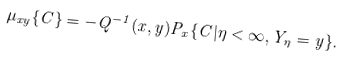<formula> <loc_0><loc_0><loc_500><loc_500>\mu _ { x y } \{ C \} = - Q ^ { - 1 } ( x , y ) { P } _ { x } \{ C | \eta < \infty , Y _ { \eta } = y \} .</formula> 